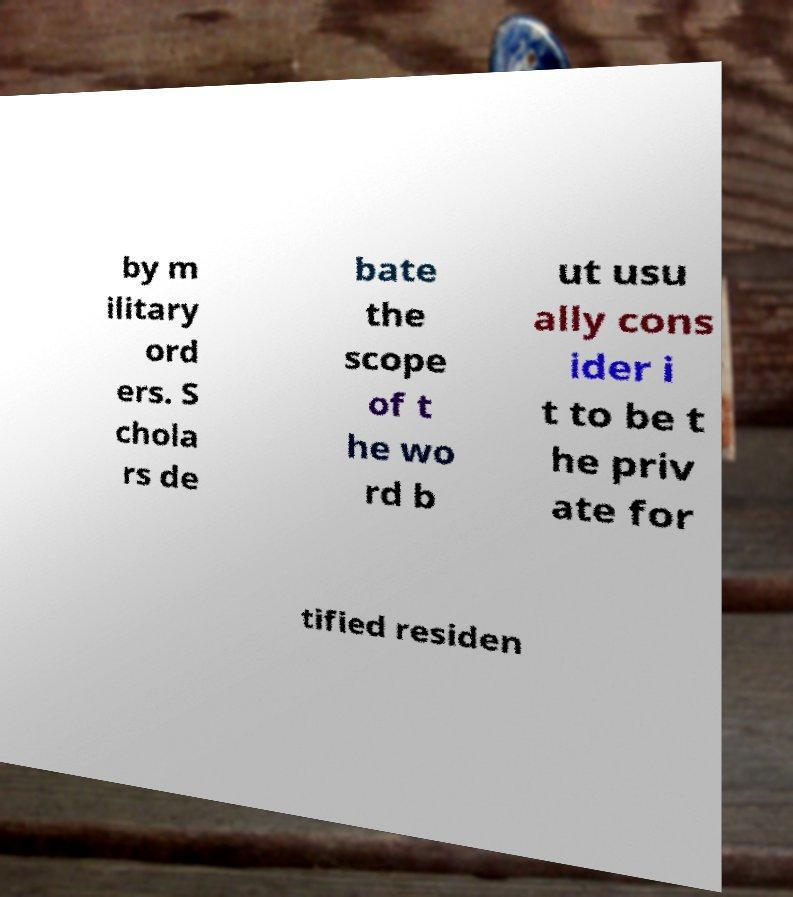There's text embedded in this image that I need extracted. Can you transcribe it verbatim? by m ilitary ord ers. S chola rs de bate the scope of t he wo rd b ut usu ally cons ider i t to be t he priv ate for tified residen 